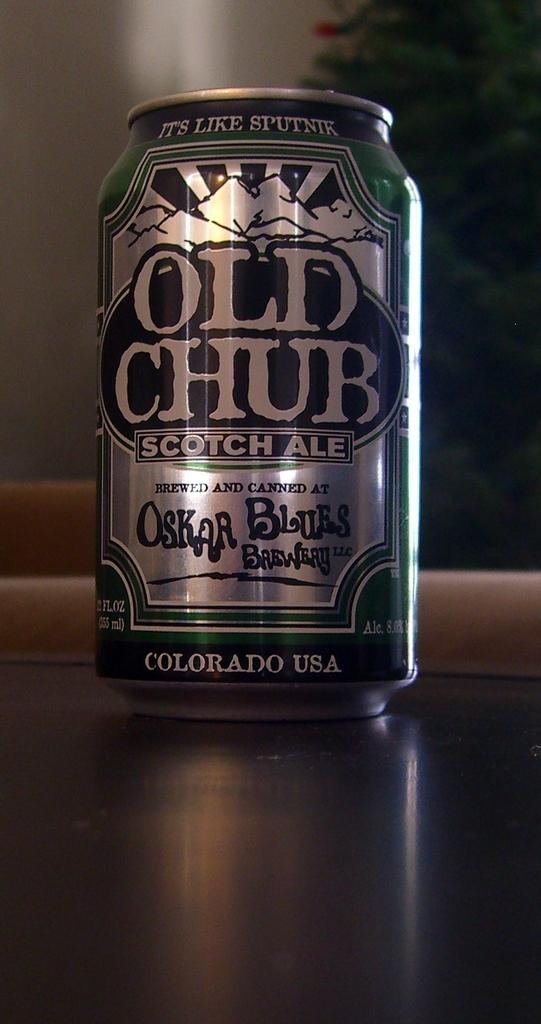<image>
Create a compact narrative representing the image presented. A can of Old Chub Scotch Ale sits on a counter. 